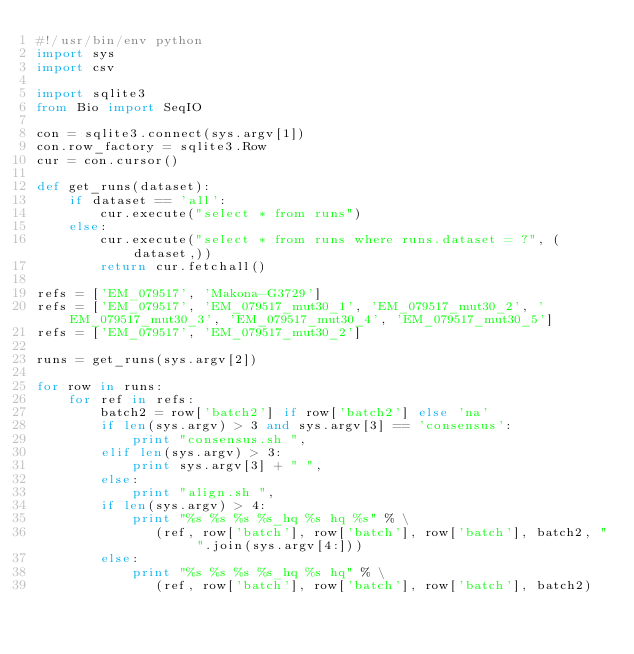<code> <loc_0><loc_0><loc_500><loc_500><_Python_>#!/usr/bin/env python
import sys
import csv

import sqlite3
from Bio import SeqIO

con = sqlite3.connect(sys.argv[1])
con.row_factory = sqlite3.Row
cur = con.cursor()

def get_runs(dataset):
	if dataset == 'all':
		cur.execute("select * from runs")
	else:
		cur.execute("select * from runs where runs.dataset = ?", (dataset,))
        return cur.fetchall()

refs = ['EM_079517', 'Makona-G3729']
refs = ['EM_079517', 'EM_079517_mut30_1', 'EM_079517_mut30_2', 'EM_079517_mut30_3', 'EM_079517_mut30_4', 'EM_079517_mut30_5']
refs = ['EM_079517', 'EM_079517_mut30_2']

runs = get_runs(sys.argv[2])

for row in runs:
	for ref in refs:
		batch2 = row['batch2'] if row['batch2'] else 'na'
		if len(sys.argv) > 3 and sys.argv[3] == 'consensus':
			print "consensus.sh ",
		elif len(sys.argv) > 3:
			print sys.argv[3] + " ",
		else:
			print "align.sh ",
		if len(sys.argv) > 4:
			print "%s %s %s %s_hq %s hq %s" % \
			   (ref, row['batch'], row['batch'], row['batch'], batch2, " ".join(sys.argv[4:]))
		else:
			print "%s %s %s %s_hq %s hq" % \
			   (ref, row['batch'], row['batch'], row['batch'], batch2)
</code> 